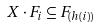<formula> <loc_0><loc_0><loc_500><loc_500>X \cdot F _ { i } \subseteq F _ { ( h ( i ) ) }</formula> 